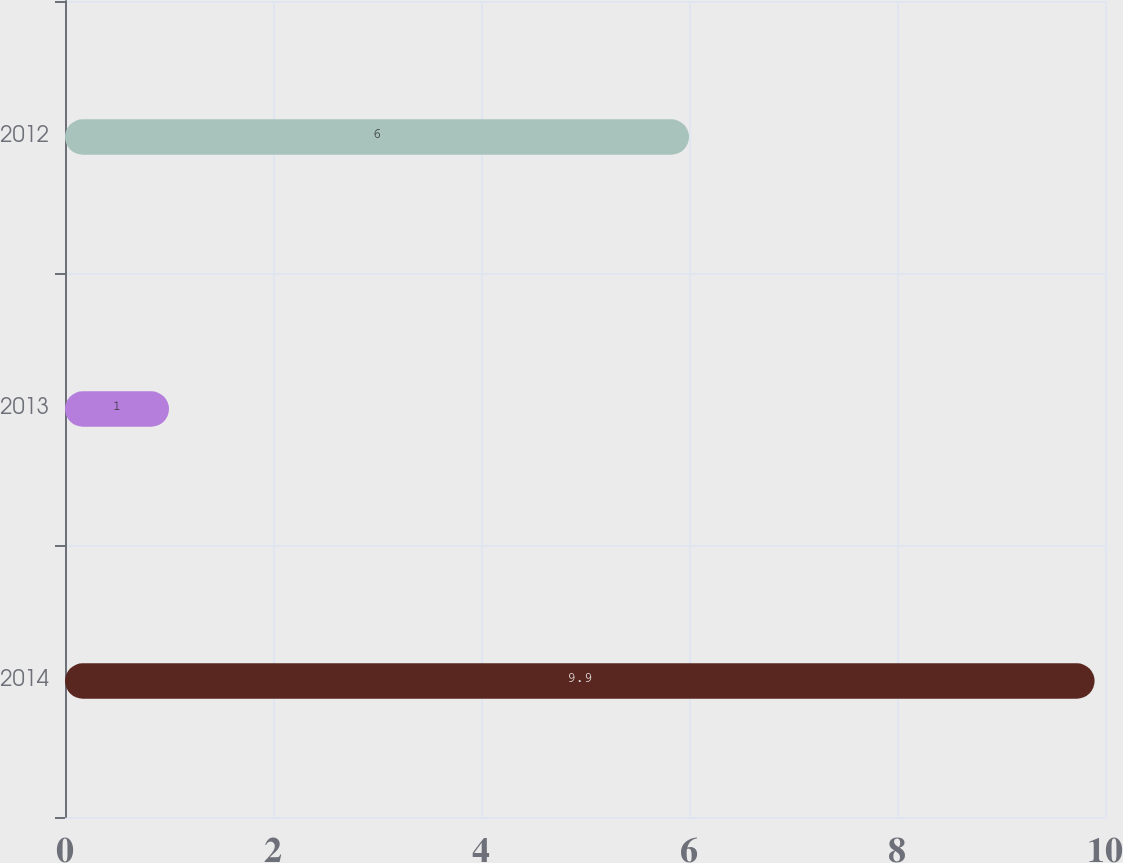<chart> <loc_0><loc_0><loc_500><loc_500><bar_chart><fcel>2014<fcel>2013<fcel>2012<nl><fcel>9.9<fcel>1<fcel>6<nl></chart> 